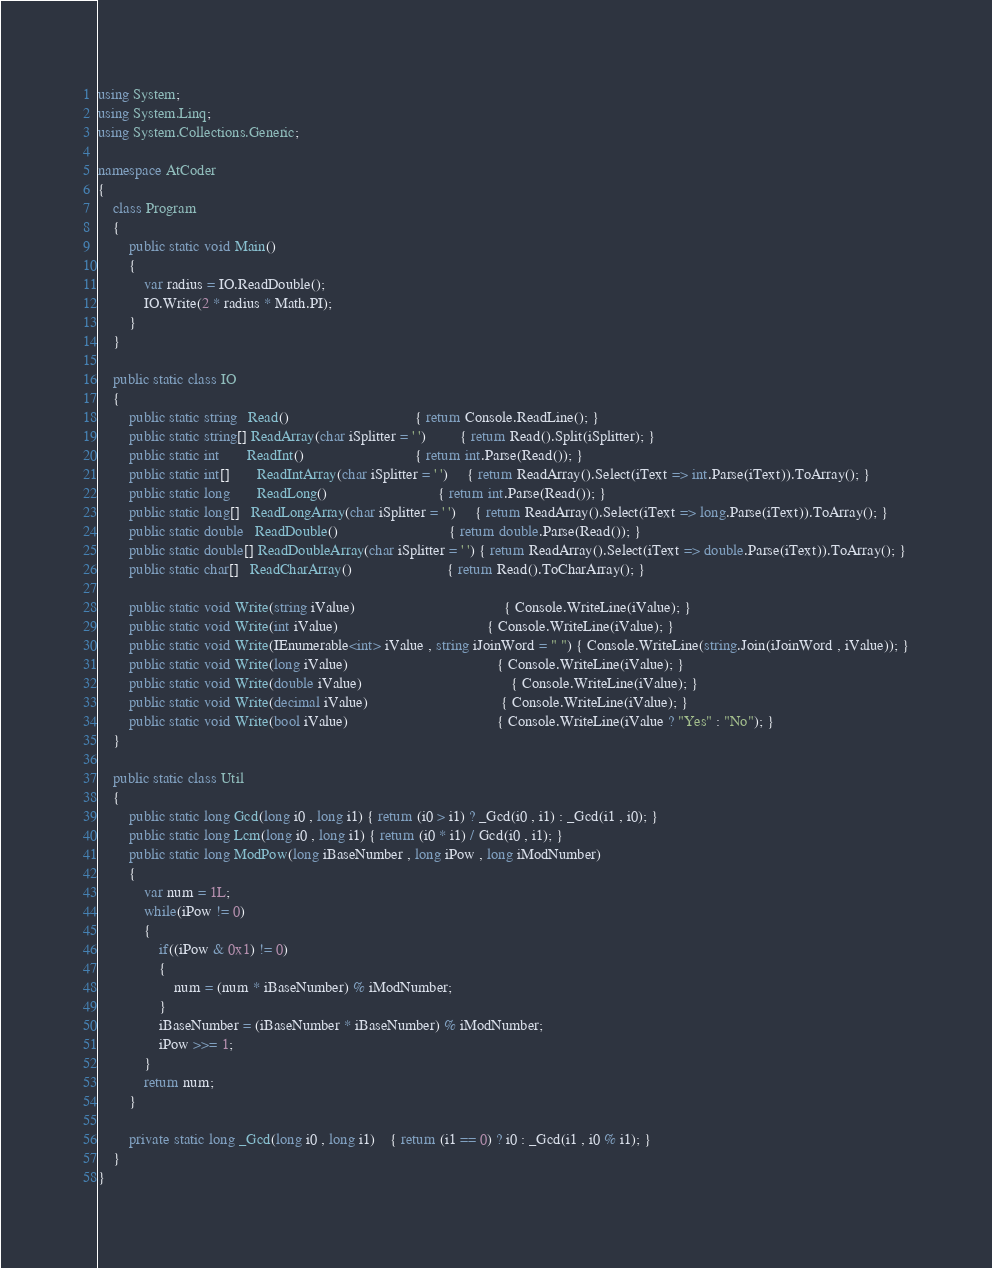Convert code to text. <code><loc_0><loc_0><loc_500><loc_500><_C#_>using System;
using System.Linq;
using System.Collections.Generic;

namespace AtCoder
{
	class Program
	{
		public static void Main()
		{
			var radius = IO.ReadDouble();
			IO.Write(2 * radius * Math.PI);
		}
	}

	public static class IO
	{
		public static string   Read()								 { return Console.ReadLine(); }
		public static string[] ReadArray(char iSplitter = ' ')		 { return Read().Split(iSplitter); }
		public static int	   ReadInt()							 { return int.Parse(Read()); }
		public static int[]	   ReadIntArray(char iSplitter = ' ')	 { return ReadArray().Select(iText => int.Parse(iText)).ToArray(); }
		public static long	   ReadLong()							 { return int.Parse(Read()); }
		public static long[]   ReadLongArray(char iSplitter = ' ')	 { return ReadArray().Select(iText => long.Parse(iText)).ToArray(); }
		public static double   ReadDouble()							 { return double.Parse(Read()); }
		public static double[] ReadDoubleArray(char iSplitter = ' ') { return ReadArray().Select(iText => double.Parse(iText)).ToArray(); }
		public static char[]   ReadCharArray()						 { return Read().ToCharArray(); }

		public static void Write(string iValue)									   { Console.WriteLine(iValue); }
		public static void Write(int iValue)									   { Console.WriteLine(iValue); }
		public static void Write(IEnumerable<int> iValue , string iJoinWord = " ") { Console.WriteLine(string.Join(iJoinWord , iValue)); }
		public static void Write(long iValue)									   { Console.WriteLine(iValue); }
		public static void Write(double iValue)									   { Console.WriteLine(iValue); }
		public static void Write(decimal iValue)								   { Console.WriteLine(iValue); }
		public static void Write(bool iValue)									   { Console.WriteLine(iValue ? "Yes" : "No"); }
	}

	public static class Util
	{
		public static long Gcd(long i0 , long i1) { return (i0 > i1) ? _Gcd(i0 , i1) : _Gcd(i1 , i0); }
		public static long Lcm(long i0 , long i1) { return (i0 * i1) / Gcd(i0 , i1); }
		public static long ModPow(long iBaseNumber , long iPow , long iModNumber)
		{
			var num = 1L;
			while(iPow != 0)
			{
				if((iPow & 0x1) != 0)
				{
					num = (num * iBaseNumber) % iModNumber;
				}
				iBaseNumber = (iBaseNumber * iBaseNumber) % iModNumber;
				iPow >>= 1;
			}
			return num;
		}

		private static long _Gcd(long i0 , long i1)	{ return (i1 == 0) ? i0 : _Gcd(i1 , i0 % i1); }
	}
}
</code> 